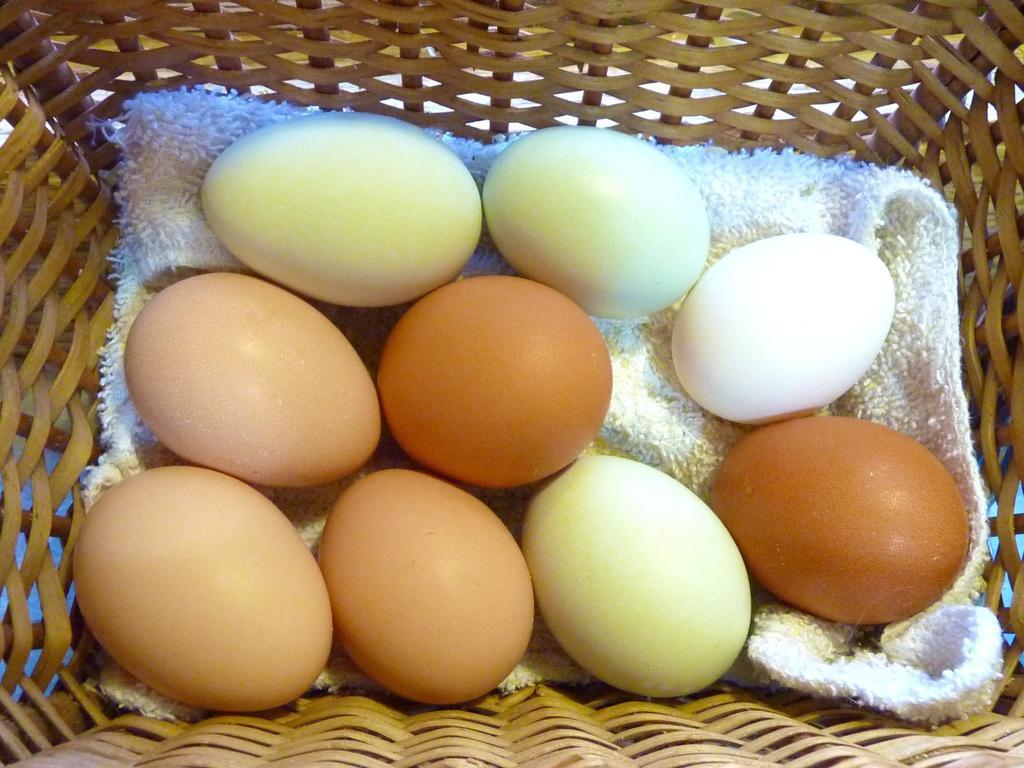How would you summarize this image in a sentence or two? In this image there is a basket. In the basket there are so many eggs kept on the cloth. 